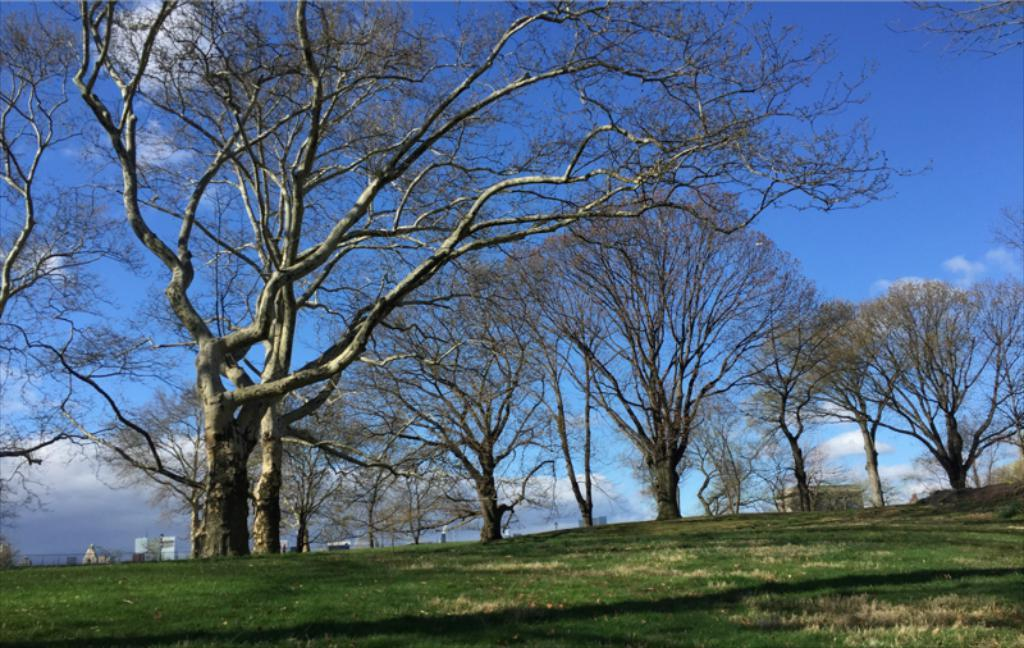What type of vegetation can be seen in the image? There are trees in the image. What type of man-made structures are visible in the image? There are buildings in the image. What type of barrier can be seen in the image? There is a fence in the image. What type of ground surface is visible in the image? The ground with grass is visible in the image. What type of objects can be seen in the image? There are objects in the image, but their specific nature is not mentioned in the facts. What part of the natural environment is visible in the image? The sky is visible in the image. What type of atmospheric conditions can be seen in the sky? Clouds are present in the sky. How many straws are floating in the water near the dock in the image? There is no dock or straws present in the image. What type of pollution can be seen in the image? There is no mention of pollution in the image. 